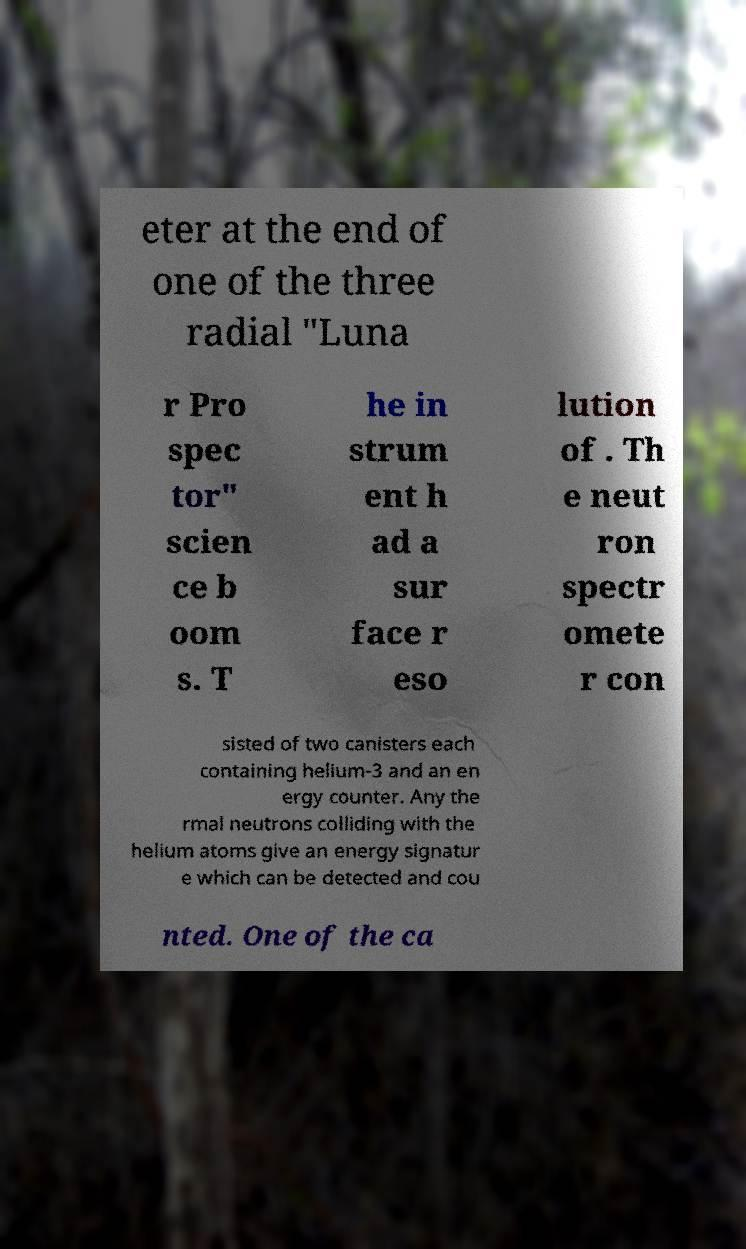What messages or text are displayed in this image? I need them in a readable, typed format. eter at the end of one of the three radial "Luna r Pro spec tor" scien ce b oom s. T he in strum ent h ad a sur face r eso lution of . Th e neut ron spectr omete r con sisted of two canisters each containing helium-3 and an en ergy counter. Any the rmal neutrons colliding with the helium atoms give an energy signatur e which can be detected and cou nted. One of the ca 